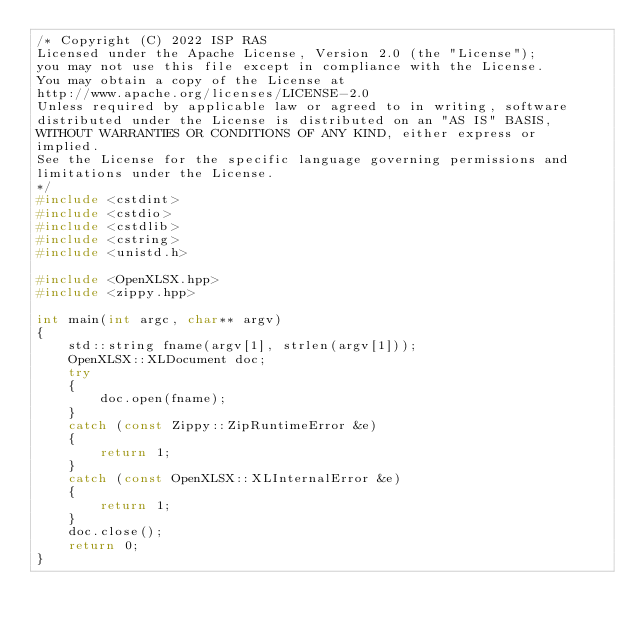<code> <loc_0><loc_0><loc_500><loc_500><_C++_>/* Copyright (C) 2022 ISP RAS
Licensed under the Apache License, Version 2.0 (the "License");
you may not use this file except in compliance with the License.
You may obtain a copy of the License at
http://www.apache.org/licenses/LICENSE-2.0
Unless required by applicable law or agreed to in writing, software
distributed under the License is distributed on an "AS IS" BASIS,
WITHOUT WARRANTIES OR CONDITIONS OF ANY KIND, either express or
implied.
See the License for the specific language governing permissions and
limitations under the License.
*/
#include <cstdint>
#include <cstdio>
#include <cstdlib>
#include <cstring>
#include <unistd.h>

#include <OpenXLSX.hpp>
#include <zippy.hpp>

int main(int argc, char** argv)
{
    std::string fname(argv[1], strlen(argv[1]));
    OpenXLSX::XLDocument doc;
    try
    {
        doc.open(fname);
    }
    catch (const Zippy::ZipRuntimeError &e)
    {
        return 1;
    }
    catch (const OpenXLSX::XLInternalError &e)
    {
        return 1;
    }
    doc.close();
    return 0;
}
</code> 